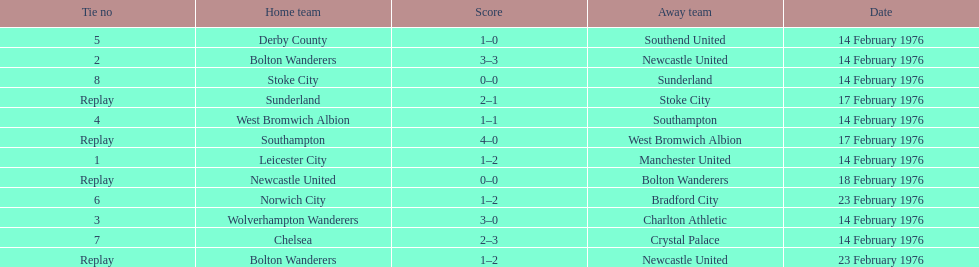Who had a better score, manchester united or wolverhampton wanderers? Wolverhampton Wanderers. 